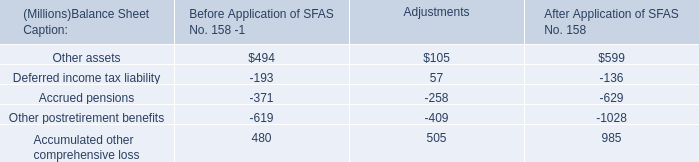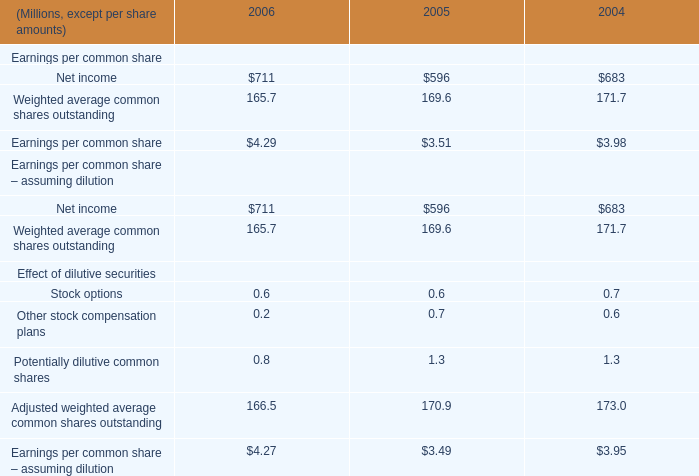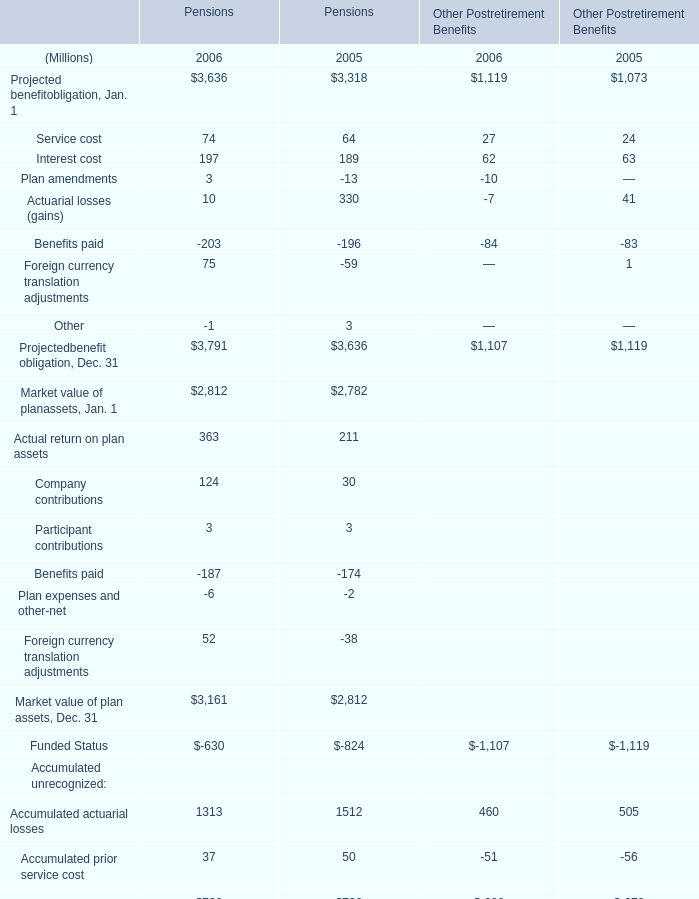what was the percentage change in the reserve for product warranties from 2005 to 2006? 
Computations: ((10 - 4) / 4)
Answer: 1.5. 